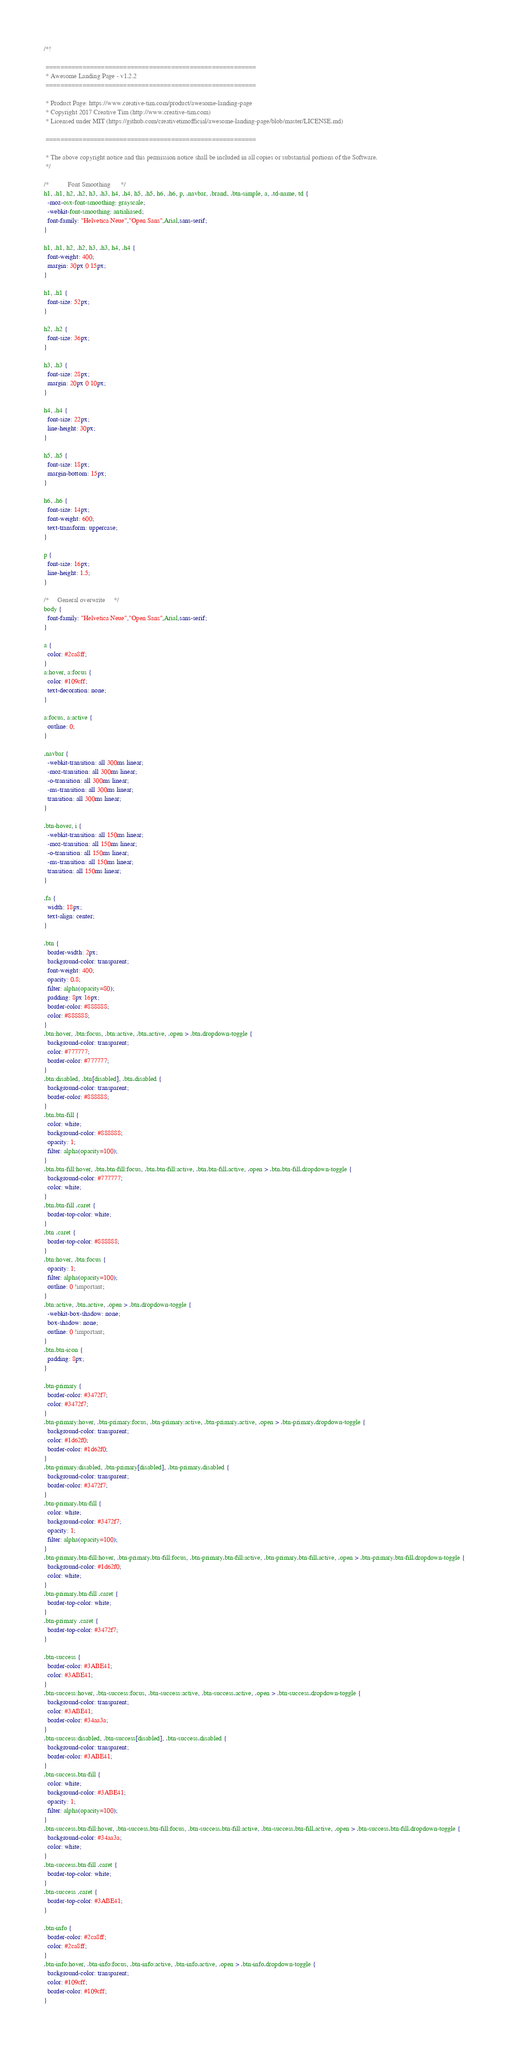Convert code to text. <code><loc_0><loc_0><loc_500><loc_500><_CSS_>/*!

 =========================================================
 * Awesome Landing Page - v1.2.2
 =========================================================

 * Product Page: https://www.creative-tim.com/product/awesome-landing-page
 * Copyright 2017 Creative Tim (http://www.creative-tim.com)
 * Licensed under MIT (https://github.com/creativetimofficial/awesome-landing-page/blob/master/LICENSE.md)

 =========================================================

 * The above copyright notice and this permission notice shall be included in all copies or substantial portions of the Software.
 */

/*           Font Smoothing      */
h1, .h1, h2, .h2, h3, .h3, h4, .h4, h5, .h5, h6, .h6, p, .navbar, .brand, .btn-simple, a, .td-name, td {
  -moz-osx-font-smoothing: grayscale;
  -webkit-font-smoothing: antialiased;
  font-family: "Helvetica Neue","Open Sans",Arial,sans-serif;
}

h1, .h1, h2, .h2, h3, .h3, h4, .h4 {
  font-weight: 400;
  margin: 30px 0 15px;
}

h1, .h1 {
  font-size: 52px;
}

h2, .h2 {
  font-size: 36px;
}

h3, .h3 {
  font-size: 28px;
  margin: 20px 0 10px;
}

h4, .h4 {
  font-size: 22px;
  line-height: 30px;
}

h5, .h5 {
  font-size: 18px;
  margin-bottom: 15px;
}

h6, .h6 {
  font-size: 14px;
  font-weight: 600;
  text-transform: uppercase;
}

p {
  font-size: 16px;
  line-height: 1.5;
}

/*     General overwrite     */
body {
  font-family: "Helvetica Neue","Open Sans",Arial,sans-serif;
}

a {
  color: #2ca8ff;
}
a:hover, a:focus {
  color: #109cff;
  text-decoration: none;
}

a:focus, a:active {
  outline: 0;
}

.navbar {
  -webkit-transition: all 300ms linear;
  -moz-transition: all 300ms linear;
  -o-transition: all 300ms linear;
  -ms-transition: all 300ms linear;
  transition: all 300ms linear;
}

.btn-hover, i {
  -webkit-transition: all 150ms linear;
  -moz-transition: all 150ms linear;
  -o-transition: all 150ms linear;
  -ms-transition: all 150ms linear;
  transition: all 150ms linear;
}

.fa {
  width: 18px;
  text-align: center;
}

.btn {
  border-width: 2px;
  background-color: transparent;
  font-weight: 400;
  opacity: 0.8;
  filter: alpha(opacity=80);
  padding: 8px 16px;
  border-color: #888888;
  color: #888888;
}
.btn:hover, .btn:focus, .btn:active, .btn.active, .open > .btn.dropdown-toggle {
  background-color: transparent;
  color: #777777;
  border-color: #777777;
}
.btn:disabled, .btn[disabled], .btn.disabled {
  background-color: transparent;
  border-color: #888888;
}
.btn.btn-fill {
  color: white;
  background-color: #888888;
  opacity: 1;
  filter: alpha(opacity=100);
}
.btn.btn-fill:hover, .btn.btn-fill:focus, .btn.btn-fill:active, .btn.btn-fill.active, .open > .btn.btn-fill.dropdown-toggle {
  background-color: #777777;
  color: white;
}
.btn.btn-fill .caret {
  border-top-color: white;
}
.btn .caret {
  border-top-color: #888888;
}
.btn:hover, .btn:focus {
  opacity: 1;
  filter: alpha(opacity=100);
  outline: 0 !important;
}
.btn:active, .btn.active, .open > .btn.dropdown-toggle {
  -webkit-box-shadow: none;
  box-shadow: none;
  outline: 0 !important;
}
.btn.btn-icon {
  padding: 8px;
}

.btn-primary {
  border-color: #3472f7;
  color: #3472f7;
}
.btn-primary:hover, .btn-primary:focus, .btn-primary:active, .btn-primary.active, .open > .btn-primary.dropdown-toggle {
  background-color: transparent;
  color: #1d62f0;
  border-color: #1d62f0;
}
.btn-primary:disabled, .btn-primary[disabled], .btn-primary.disabled {
  background-color: transparent;
  border-color: #3472f7;
}
.btn-primary.btn-fill {
  color: white;
  background-color: #3472f7;
  opacity: 1;
  filter: alpha(opacity=100);
}
.btn-primary.btn-fill:hover, .btn-primary.btn-fill:focus, .btn-primary.btn-fill:active, .btn-primary.btn-fill.active, .open > .btn-primary.btn-fill.dropdown-toggle {
  background-color: #1d62f0;
  color: white;
}
.btn-primary.btn-fill .caret {
  border-top-color: white;
}
.btn-primary .caret {
  border-top-color: #3472f7;
}

.btn-success {
  border-color: #3ABE41;
  color: #3ABE41;
}
.btn-success:hover, .btn-success:focus, .btn-success:active, .btn-success.active, .open > .btn-success.dropdown-toggle {
  background-color: transparent;
  color: #3ABE41;
  border-color: #34aa3a;
}
.btn-success:disabled, .btn-success[disabled], .btn-success.disabled {
  background-color: transparent;
  border-color: #3ABE41;
}
.btn-success.btn-fill {
  color: white;
  background-color: #3ABE41;
  opacity: 1;
  filter: alpha(opacity=100);
}
.btn-success.btn-fill:hover, .btn-success.btn-fill:focus, .btn-success.btn-fill:active, .btn-success.btn-fill.active, .open > .btn-success.btn-fill.dropdown-toggle {
  background-color: #34aa3a;
  color: white;
}
.btn-success.btn-fill .caret {
  border-top-color: white;
}
.btn-success .caret {
  border-top-color: #3ABE41;
}

.btn-info {
  border-color: #2ca8ff;
  color: #2ca8ff;
}
.btn-info:hover, .btn-info:focus, .btn-info:active, .btn-info.active, .open > .btn-info.dropdown-toggle {
  background-color: transparent;
  color: #109cff;
  border-color: #109cff;
}</code> 